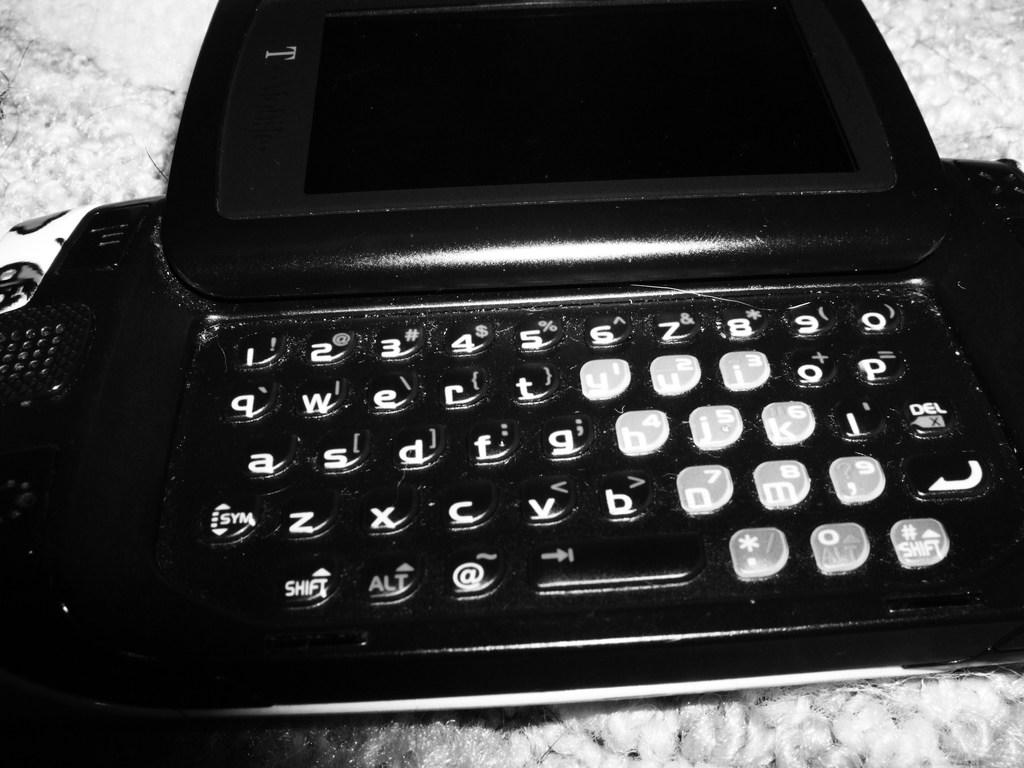<image>
Create a compact narrative representing the image presented. A old laptop with big keys and one key says sym on it . 